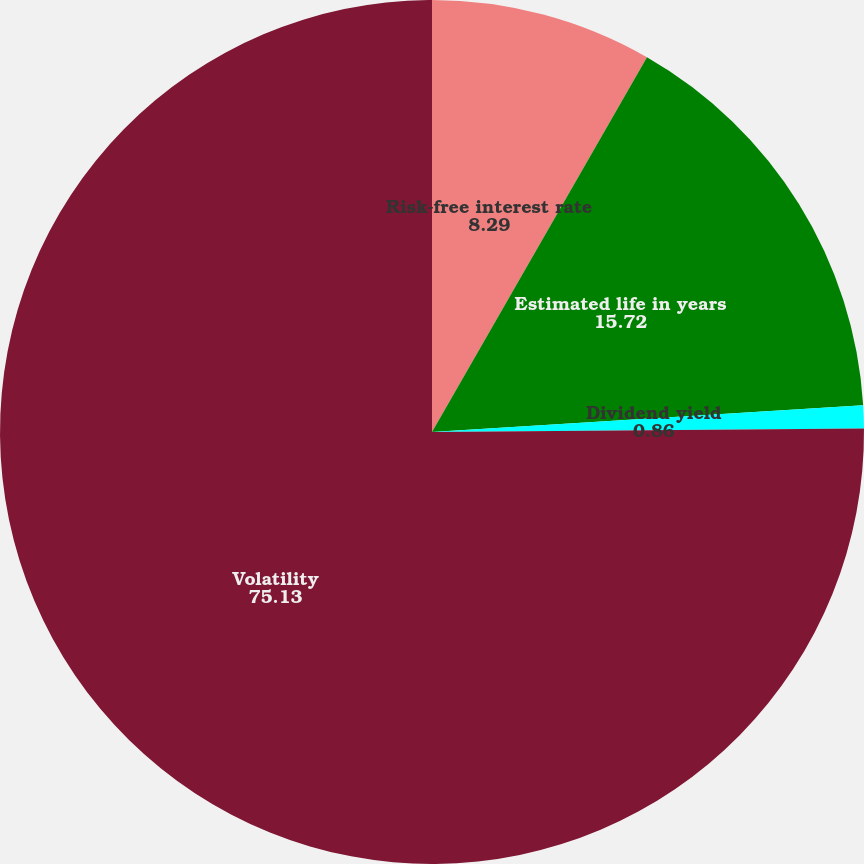<chart> <loc_0><loc_0><loc_500><loc_500><pie_chart><fcel>Risk-free interest rate<fcel>Estimated life in years<fcel>Dividend yield<fcel>Volatility<nl><fcel>8.29%<fcel>15.72%<fcel>0.86%<fcel>75.13%<nl></chart> 